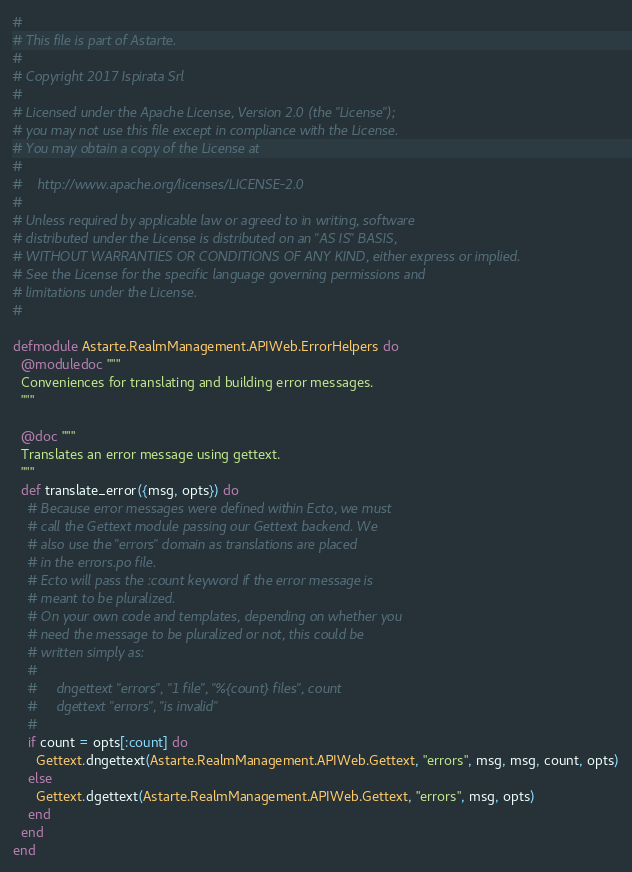Convert code to text. <code><loc_0><loc_0><loc_500><loc_500><_Elixir_>#
# This file is part of Astarte.
#
# Copyright 2017 Ispirata Srl
#
# Licensed under the Apache License, Version 2.0 (the "License");
# you may not use this file except in compliance with the License.
# You may obtain a copy of the License at
#
#    http://www.apache.org/licenses/LICENSE-2.0
#
# Unless required by applicable law or agreed to in writing, software
# distributed under the License is distributed on an "AS IS" BASIS,
# WITHOUT WARRANTIES OR CONDITIONS OF ANY KIND, either express or implied.
# See the License for the specific language governing permissions and
# limitations under the License.
#

defmodule Astarte.RealmManagement.APIWeb.ErrorHelpers do
  @moduledoc """
  Conveniences for translating and building error messages.
  """

  @doc """
  Translates an error message using gettext.
  """
  def translate_error({msg, opts}) do
    # Because error messages were defined within Ecto, we must
    # call the Gettext module passing our Gettext backend. We
    # also use the "errors" domain as translations are placed
    # in the errors.po file.
    # Ecto will pass the :count keyword if the error message is
    # meant to be pluralized.
    # On your own code and templates, depending on whether you
    # need the message to be pluralized or not, this could be
    # written simply as:
    #
    #     dngettext "errors", "1 file", "%{count} files", count
    #     dgettext "errors", "is invalid"
    #
    if count = opts[:count] do
      Gettext.dngettext(Astarte.RealmManagement.APIWeb.Gettext, "errors", msg, msg, count, opts)
    else
      Gettext.dgettext(Astarte.RealmManagement.APIWeb.Gettext, "errors", msg, opts)
    end
  end
end
</code> 